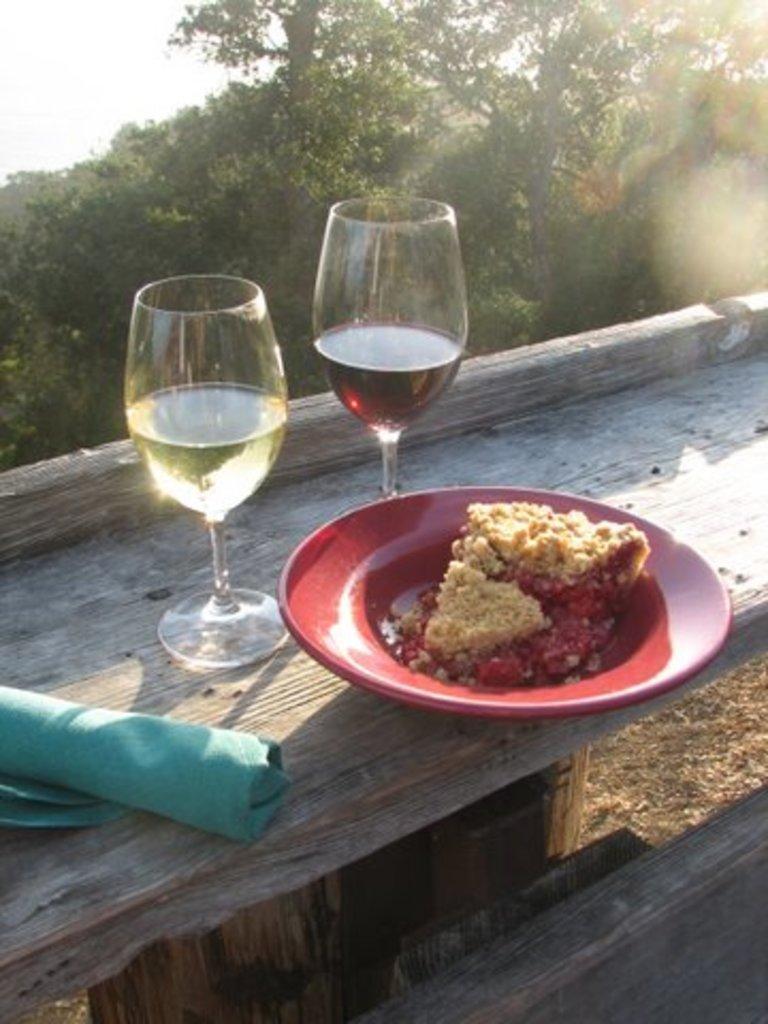How would you summarize this image in a sentence or two? In the center of the image there is a plate containing food, wine glasses and a napkin placed on the bench. In the background there are trees and sky. 